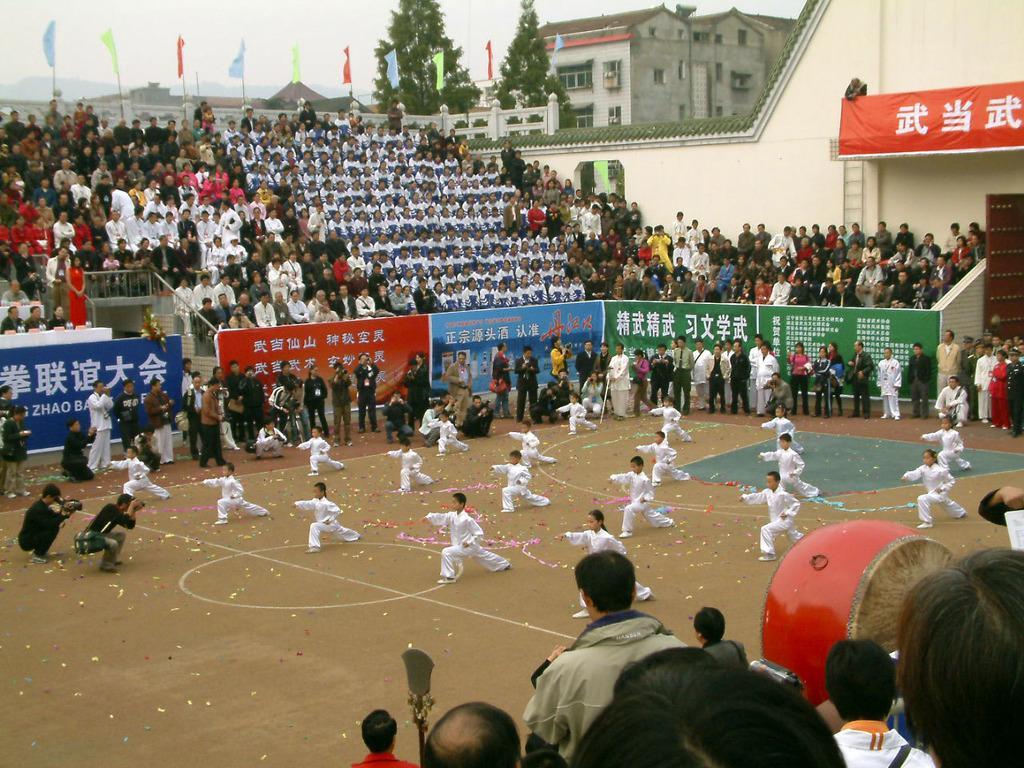In one or two sentences, can you explain what this image depicts? This picture might be taken in a stadium, in this picture in the center there are some people who are doing karate. And in the background there are a group of people who are sitting and watching and also some of them are standing and some of them are holding cameras. At the bottom there are some people, and in the background there are some houses, trees and mountains poles and flags. On the right side there is one house and hoarding and one door. 